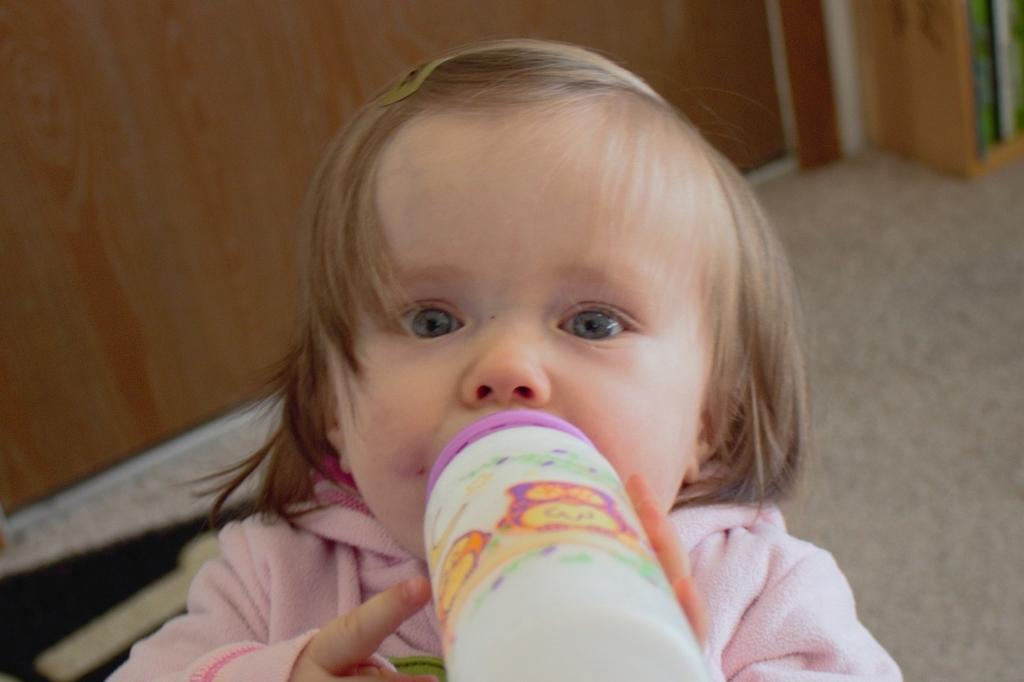What is the main subject in the foreground of the image? There is a baby in the foreground of the image. What is the baby holding in the image? The baby is holding a bottle. What is the baby doing with the bottle? The baby is drinking from the bottle. What can be seen in the background of the image? There is a wall in the background of the image. What is visible at the bottom of the image? There is a floor visible at the bottom of the image. What color is the crayon that the baby is using to draw on the wall in the image? There is no crayon present in the image, and the baby is not drawing on the wall. 